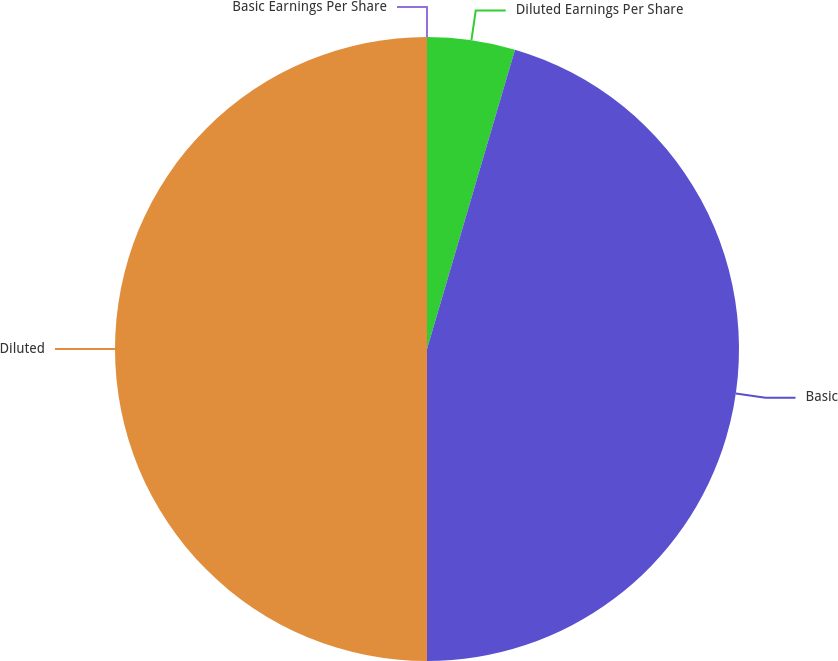<chart> <loc_0><loc_0><loc_500><loc_500><pie_chart><fcel>Basic Earnings Per Share<fcel>Diluted Earnings Per Share<fcel>Basic<fcel>Diluted<nl><fcel>0.0%<fcel>4.55%<fcel>45.45%<fcel>50.0%<nl></chart> 